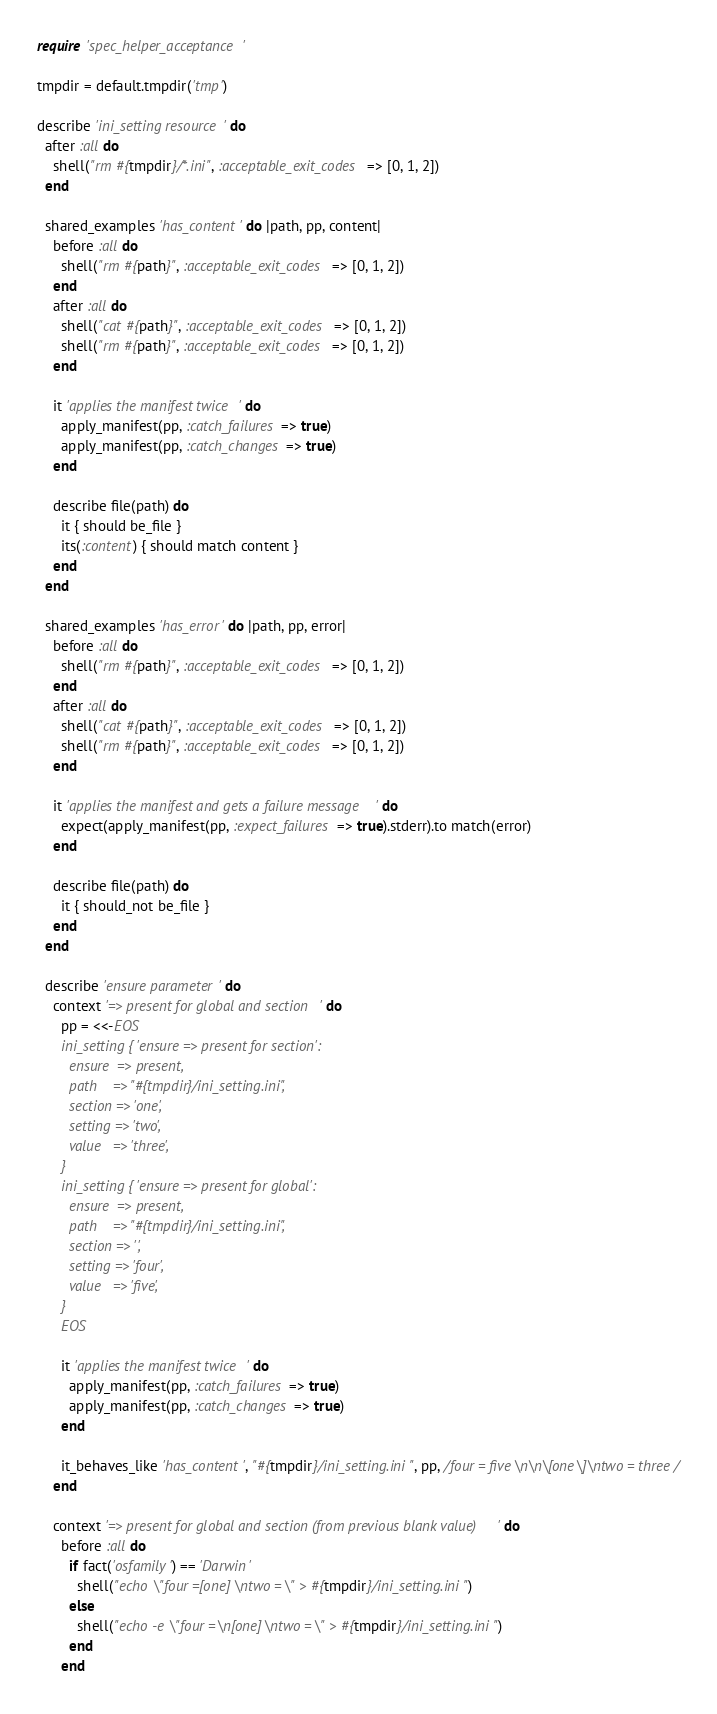Convert code to text. <code><loc_0><loc_0><loc_500><loc_500><_Ruby_>require 'spec_helper_acceptance'

tmpdir = default.tmpdir('tmp')

describe 'ini_setting resource' do
  after :all do
    shell("rm #{tmpdir}/*.ini", :acceptable_exit_codes => [0, 1, 2])
  end

  shared_examples 'has_content' do |path, pp, content|
    before :all do
      shell("rm #{path}", :acceptable_exit_codes => [0, 1, 2])
    end
    after :all do
      shell("cat #{path}", :acceptable_exit_codes => [0, 1, 2])
      shell("rm #{path}", :acceptable_exit_codes => [0, 1, 2])
    end

    it 'applies the manifest twice' do
      apply_manifest(pp, :catch_failures => true)
      apply_manifest(pp, :catch_changes => true)
    end

    describe file(path) do
      it { should be_file }
      its(:content) { should match content }
    end
  end

  shared_examples 'has_error' do |path, pp, error|
    before :all do
      shell("rm #{path}", :acceptable_exit_codes => [0, 1, 2])
    end
    after :all do
      shell("cat #{path}", :acceptable_exit_codes => [0, 1, 2])
      shell("rm #{path}", :acceptable_exit_codes => [0, 1, 2])
    end

    it 'applies the manifest and gets a failure message' do
      expect(apply_manifest(pp, :expect_failures => true).stderr).to match(error)
    end

    describe file(path) do
      it { should_not be_file }
    end
  end

  describe 'ensure parameter' do
    context '=> present for global and section' do
      pp = <<-EOS
      ini_setting { 'ensure => present for section':
        ensure  => present,
        path    => "#{tmpdir}/ini_setting.ini",
        section => 'one',
        setting => 'two',
        value   => 'three',
      }
      ini_setting { 'ensure => present for global':
        ensure  => present,
        path    => "#{tmpdir}/ini_setting.ini",
        section => '',
        setting => 'four',
        value   => 'five',
      }
      EOS

      it 'applies the manifest twice' do
        apply_manifest(pp, :catch_failures => true)
        apply_manifest(pp, :catch_changes => true)
      end

      it_behaves_like 'has_content', "#{tmpdir}/ini_setting.ini", pp, /four = five\n\n\[one\]\ntwo = three/
    end

    context '=> present for global and section (from previous blank value)' do
      before :all do
        if fact('osfamily') == 'Darwin'
          shell("echo \"four =[one]\ntwo =\" > #{tmpdir}/ini_setting.ini")
        else
          shell("echo -e \"four =\n[one]\ntwo =\" > #{tmpdir}/ini_setting.ini")
        end
      end
</code> 